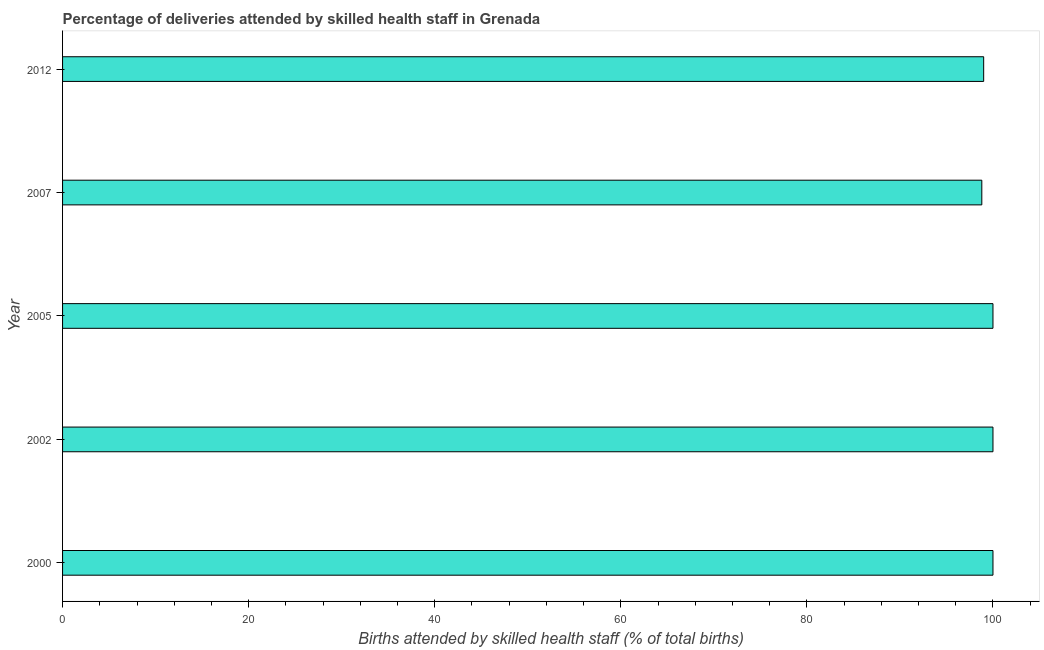Does the graph contain any zero values?
Your response must be concise. No. What is the title of the graph?
Your answer should be compact. Percentage of deliveries attended by skilled health staff in Grenada. What is the label or title of the X-axis?
Your answer should be very brief. Births attended by skilled health staff (% of total births). What is the label or title of the Y-axis?
Your answer should be compact. Year. Across all years, what is the minimum number of births attended by skilled health staff?
Offer a very short reply. 98.8. In which year was the number of births attended by skilled health staff maximum?
Provide a short and direct response. 2000. In which year was the number of births attended by skilled health staff minimum?
Ensure brevity in your answer.  2007. What is the sum of the number of births attended by skilled health staff?
Make the answer very short. 497.8. What is the average number of births attended by skilled health staff per year?
Your response must be concise. 99.56. What is the median number of births attended by skilled health staff?
Keep it short and to the point. 100. In how many years, is the number of births attended by skilled health staff greater than 60 %?
Provide a succinct answer. 5. Is the number of births attended by skilled health staff in 2000 less than that in 2002?
Offer a very short reply. No. Is the difference between the number of births attended by skilled health staff in 2002 and 2007 greater than the difference between any two years?
Your response must be concise. Yes. In how many years, is the number of births attended by skilled health staff greater than the average number of births attended by skilled health staff taken over all years?
Offer a very short reply. 3. Are all the bars in the graph horizontal?
Offer a very short reply. Yes. What is the difference between two consecutive major ticks on the X-axis?
Offer a terse response. 20. Are the values on the major ticks of X-axis written in scientific E-notation?
Provide a succinct answer. No. What is the Births attended by skilled health staff (% of total births) in 2000?
Ensure brevity in your answer.  100. What is the Births attended by skilled health staff (% of total births) in 2007?
Ensure brevity in your answer.  98.8. What is the Births attended by skilled health staff (% of total births) in 2012?
Offer a terse response. 99. What is the difference between the Births attended by skilled health staff (% of total births) in 2000 and 2005?
Provide a short and direct response. 0. What is the difference between the Births attended by skilled health staff (% of total births) in 2000 and 2007?
Offer a terse response. 1.2. What is the difference between the Births attended by skilled health staff (% of total births) in 2002 and 2005?
Provide a short and direct response. 0. What is the difference between the Births attended by skilled health staff (% of total births) in 2002 and 2012?
Offer a terse response. 1. What is the difference between the Births attended by skilled health staff (% of total births) in 2005 and 2007?
Offer a terse response. 1.2. What is the difference between the Births attended by skilled health staff (% of total births) in 2005 and 2012?
Your answer should be compact. 1. What is the difference between the Births attended by skilled health staff (% of total births) in 2007 and 2012?
Provide a succinct answer. -0.2. What is the ratio of the Births attended by skilled health staff (% of total births) in 2000 to that in 2002?
Offer a terse response. 1. What is the ratio of the Births attended by skilled health staff (% of total births) in 2000 to that in 2007?
Your answer should be compact. 1.01. What is the ratio of the Births attended by skilled health staff (% of total births) in 2000 to that in 2012?
Your response must be concise. 1.01. What is the ratio of the Births attended by skilled health staff (% of total births) in 2002 to that in 2007?
Offer a very short reply. 1.01. What is the ratio of the Births attended by skilled health staff (% of total births) in 2002 to that in 2012?
Provide a succinct answer. 1.01. 